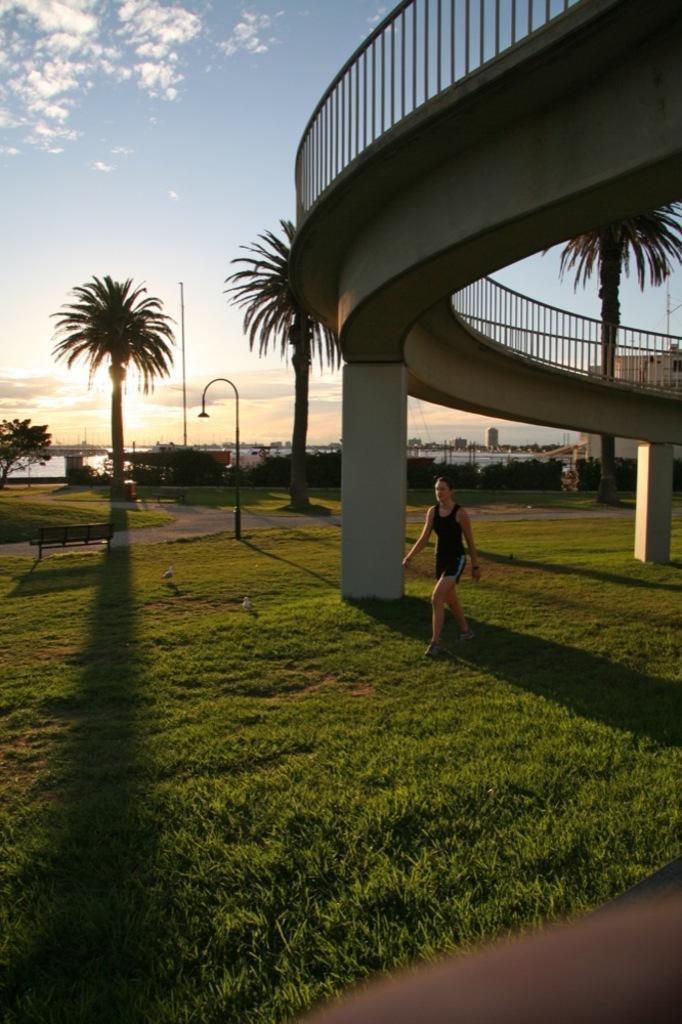Could you give a brief overview of what you see in this image? In this image in the center there is one woman who is walking, at the bottom there is grass and on the right side there is a bridge and railing. In the background there are some trees, plants, poles. At the top of the image there is sky. 